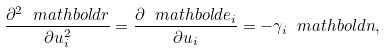<formula> <loc_0><loc_0><loc_500><loc_500>\frac { \partial ^ { 2 } { \ m a t h b o l d r } } { \partial u _ { i } ^ { 2 } } = \frac { \partial { \ m a t h b o l d e } _ { i } } { \partial u _ { i } } = - \gamma _ { i } { \ m a t h b o l d n } ,</formula> 